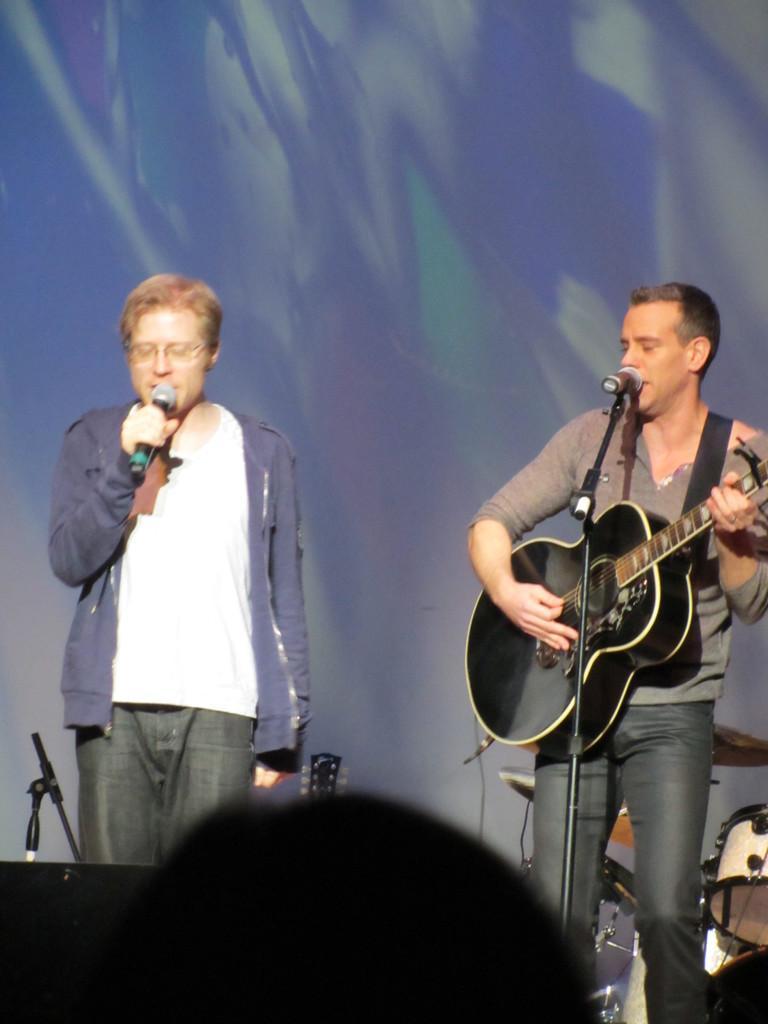In one or two sentences, can you explain what this image depicts? In this picture there are two members standing. One of them was singing holding a mic in their hand and the other guy was playing a guitar in his hands. In the background there are drums. There is a wall here. 